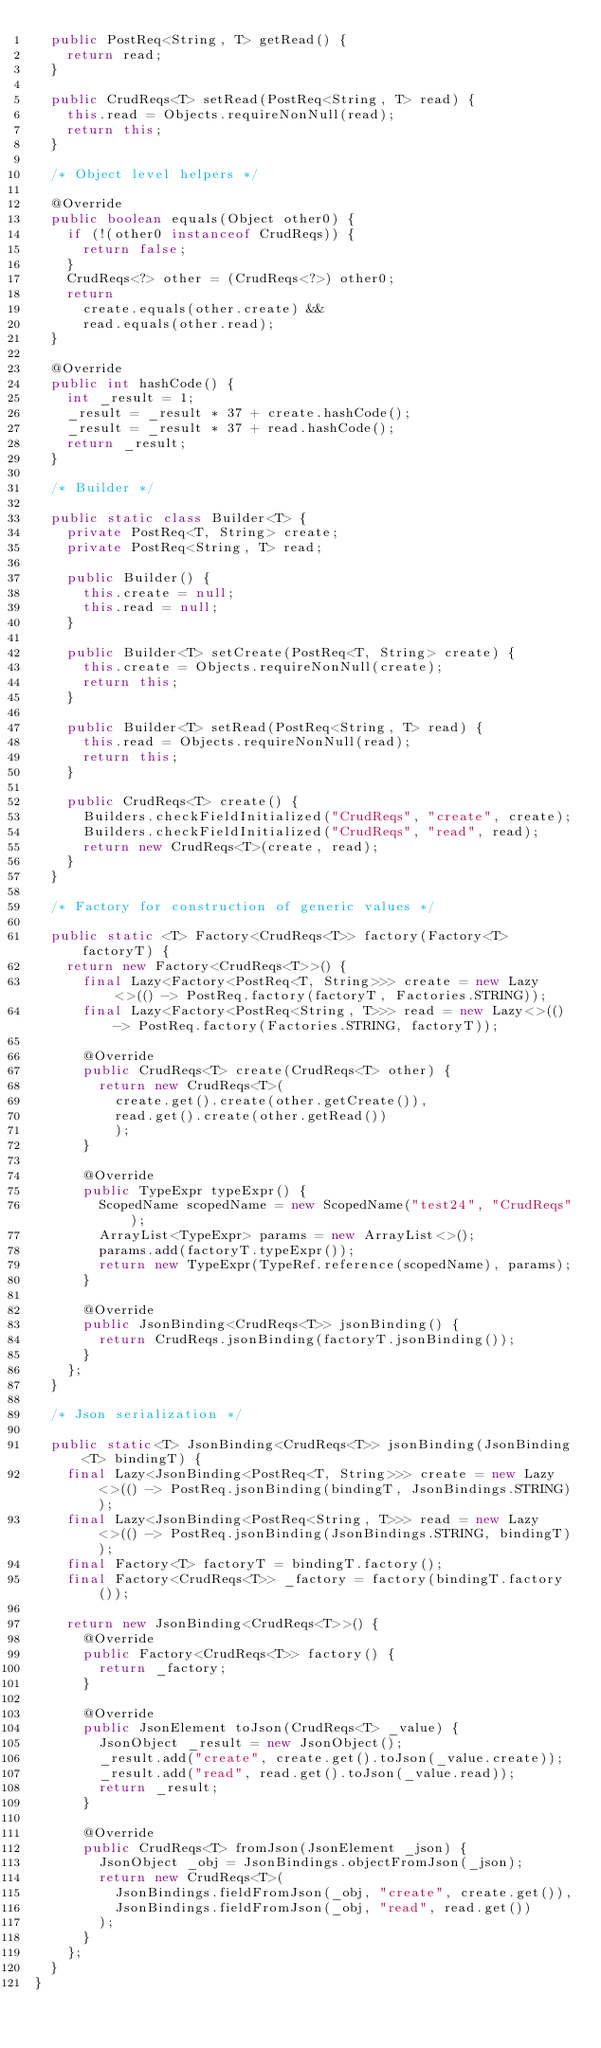<code> <loc_0><loc_0><loc_500><loc_500><_Java_>  public PostReq<String, T> getRead() {
    return read;
  }

  public CrudReqs<T> setRead(PostReq<String, T> read) {
    this.read = Objects.requireNonNull(read);
    return this;
  }

  /* Object level helpers */

  @Override
  public boolean equals(Object other0) {
    if (!(other0 instanceof CrudReqs)) {
      return false;
    }
    CrudReqs<?> other = (CrudReqs<?>) other0;
    return
      create.equals(other.create) &&
      read.equals(other.read);
  }

  @Override
  public int hashCode() {
    int _result = 1;
    _result = _result * 37 + create.hashCode();
    _result = _result * 37 + read.hashCode();
    return _result;
  }

  /* Builder */

  public static class Builder<T> {
    private PostReq<T, String> create;
    private PostReq<String, T> read;

    public Builder() {
      this.create = null;
      this.read = null;
    }

    public Builder<T> setCreate(PostReq<T, String> create) {
      this.create = Objects.requireNonNull(create);
      return this;
    }

    public Builder<T> setRead(PostReq<String, T> read) {
      this.read = Objects.requireNonNull(read);
      return this;
    }

    public CrudReqs<T> create() {
      Builders.checkFieldInitialized("CrudReqs", "create", create);
      Builders.checkFieldInitialized("CrudReqs", "read", read);
      return new CrudReqs<T>(create, read);
    }
  }

  /* Factory for construction of generic values */

  public static <T> Factory<CrudReqs<T>> factory(Factory<T> factoryT) {
    return new Factory<CrudReqs<T>>() {
      final Lazy<Factory<PostReq<T, String>>> create = new Lazy<>(() -> PostReq.factory(factoryT, Factories.STRING));
      final Lazy<Factory<PostReq<String, T>>> read = new Lazy<>(() -> PostReq.factory(Factories.STRING, factoryT));

      @Override
      public CrudReqs<T> create(CrudReqs<T> other) {
        return new CrudReqs<T>(
          create.get().create(other.getCreate()),
          read.get().create(other.getRead())
          );
      }

      @Override
      public TypeExpr typeExpr() {
        ScopedName scopedName = new ScopedName("test24", "CrudReqs");
        ArrayList<TypeExpr> params = new ArrayList<>();
        params.add(factoryT.typeExpr());
        return new TypeExpr(TypeRef.reference(scopedName), params);
      }

      @Override
      public JsonBinding<CrudReqs<T>> jsonBinding() {
        return CrudReqs.jsonBinding(factoryT.jsonBinding());
      }
    };
  }

  /* Json serialization */

  public static<T> JsonBinding<CrudReqs<T>> jsonBinding(JsonBinding<T> bindingT) {
    final Lazy<JsonBinding<PostReq<T, String>>> create = new Lazy<>(() -> PostReq.jsonBinding(bindingT, JsonBindings.STRING));
    final Lazy<JsonBinding<PostReq<String, T>>> read = new Lazy<>(() -> PostReq.jsonBinding(JsonBindings.STRING, bindingT));
    final Factory<T> factoryT = bindingT.factory();
    final Factory<CrudReqs<T>> _factory = factory(bindingT.factory());

    return new JsonBinding<CrudReqs<T>>() {
      @Override
      public Factory<CrudReqs<T>> factory() {
        return _factory;
      }

      @Override
      public JsonElement toJson(CrudReqs<T> _value) {
        JsonObject _result = new JsonObject();
        _result.add("create", create.get().toJson(_value.create));
        _result.add("read", read.get().toJson(_value.read));
        return _result;
      }

      @Override
      public CrudReqs<T> fromJson(JsonElement _json) {
        JsonObject _obj = JsonBindings.objectFromJson(_json);
        return new CrudReqs<T>(
          JsonBindings.fieldFromJson(_obj, "create", create.get()),
          JsonBindings.fieldFromJson(_obj, "read", read.get())
        );
      }
    };
  }
}
</code> 